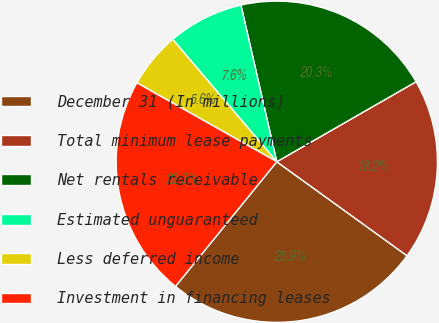Convert chart to OTSL. <chart><loc_0><loc_0><loc_500><loc_500><pie_chart><fcel>December 31 (In millions)<fcel>Total minimum lease payments<fcel>Net rentals receivable<fcel>Estimated unguaranteed<fcel>Less deferred income<fcel>Investment in financing leases<nl><fcel>25.91%<fcel>18.25%<fcel>20.28%<fcel>7.64%<fcel>5.61%<fcel>22.31%<nl></chart> 